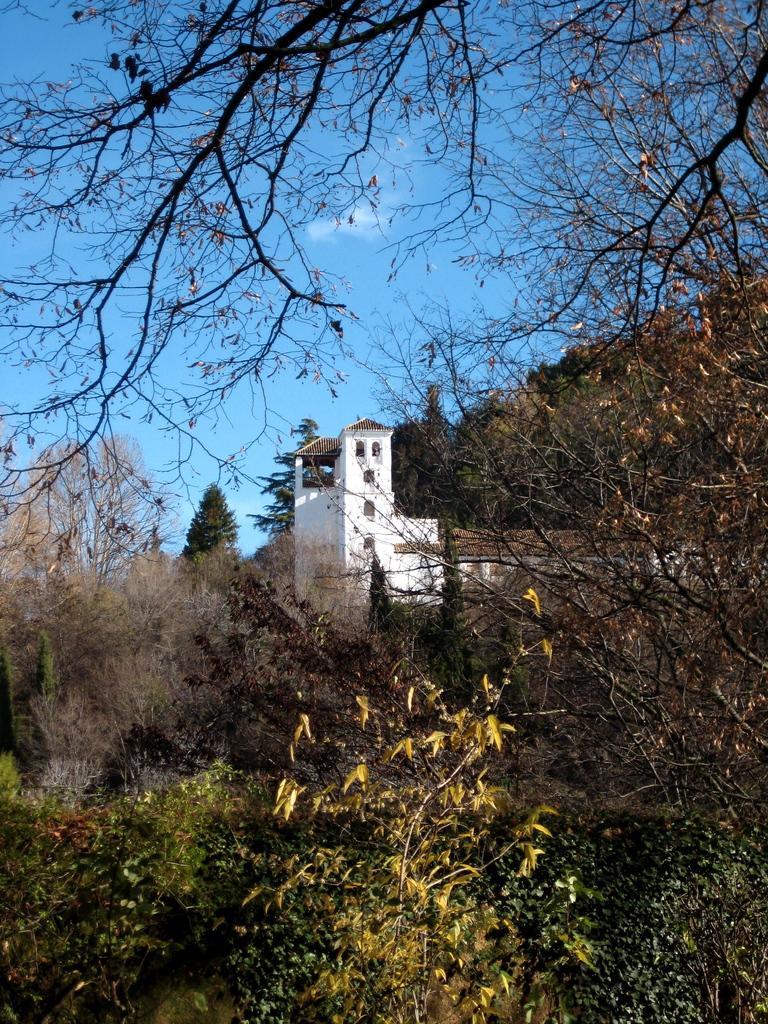How would you summarize this image in a sentence or two? In the image there is a clear sky and in between there is a white building. In Front of the building there are lot of trees and on few trees there are dry leaves. 